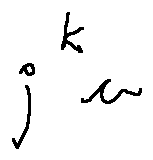Convert formula to latex. <formula><loc_0><loc_0><loc_500><loc_500>j ^ { k } u</formula> 